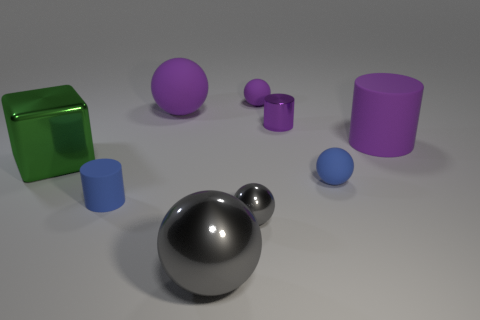Subtract all big purple balls. How many balls are left? 4 Subtract all yellow spheres. Subtract all red cylinders. How many spheres are left? 5 Add 1 big metal spheres. How many objects exist? 10 Subtract all balls. How many objects are left? 4 Add 7 tiny gray things. How many tiny gray things are left? 8 Add 8 large cubes. How many large cubes exist? 9 Subtract 0 purple blocks. How many objects are left? 9 Subtract all blue matte cylinders. Subtract all tiny brown objects. How many objects are left? 8 